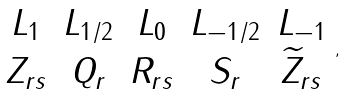<formula> <loc_0><loc_0><loc_500><loc_500>\begin{array} { c c c c c } L _ { 1 } & L _ { 1 / 2 } & L _ { 0 } & L _ { - 1 / 2 } & L _ { - 1 } \\ Z _ { r s } & Q _ { r } & R _ { r s } & S _ { r } & \widetilde { Z } _ { r s } \end{array} ,</formula> 